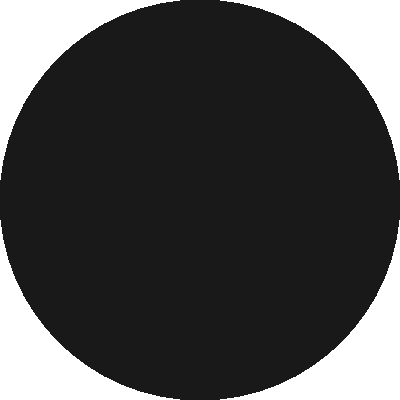Based on the before-and-after sky map, what percentage of stars are estimated to remain visible after the increase in light pollution near your rural vineyard? To determine the percentage of stars remaining visible after the increase in light pollution, we'll follow these steps:

1. Observe the "Before" and "After" sky maps.
2. Estimate the number of visible stars in each scenario:
   - Before: Approximately 50 stars
   - After: Approximately 10 stars
3. Calculate the percentage of remaining visible stars:
   $\text{Percentage} = \frac{\text{Stars visible after}}{\text{Stars visible before}} \times 100\%$
4. Plug in the values:
   $\text{Percentage} = \frac{10}{50} \times 100\% = 0.2 \times 100\% = 20\%$

Therefore, about 20% of the stars remain visible after the increase in light pollution near your rural vineyard.
Answer: 20% 